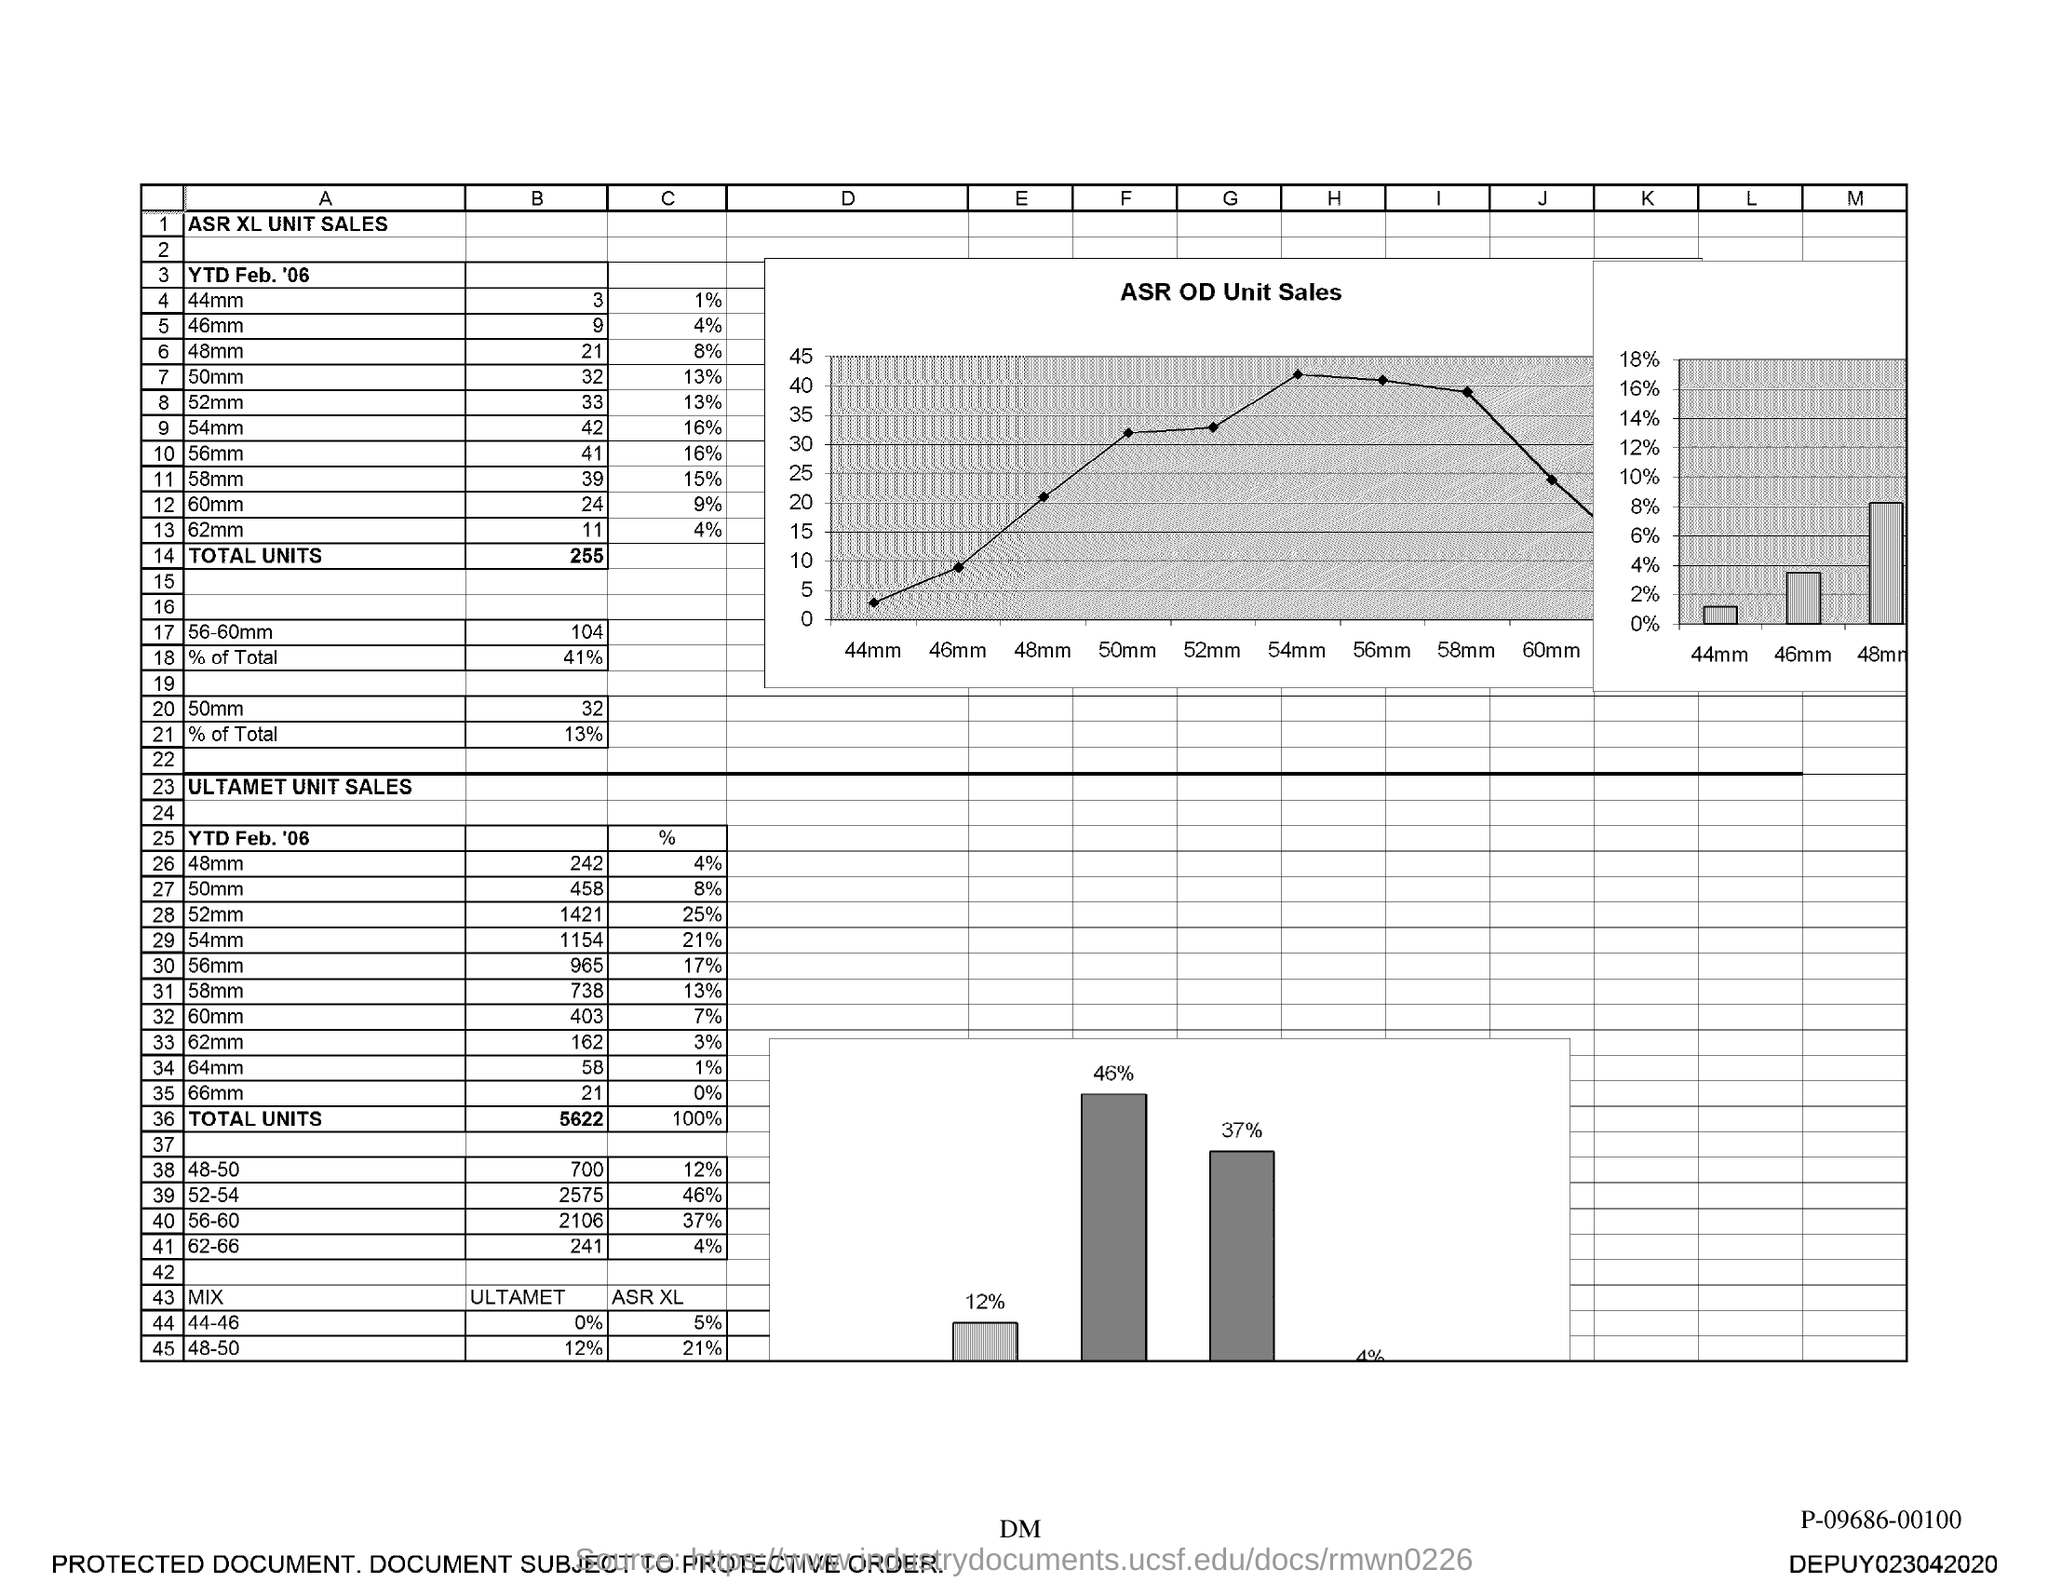Specify some key components in this picture. The ASR XL unit sales for the year-to-date period of February 2006 for a size of 44mm for the brand "B" were 3 units. The ASR XL unit sales for the year-to-date period of February 2006 for a quantity of 50mm for "B" were 32 units. The ASR XL unit sales for the year-to-date period of February 2006 for a 60mm size for "B" were 24 units. The ASR XL unit sales for the year-to-date period of February 2006 for the 54mm size for customer "B" were 42 units. For the year-to-date period of February 2006, the ASR XL unit sales for the 56mm size for customer 'B' were 41. 